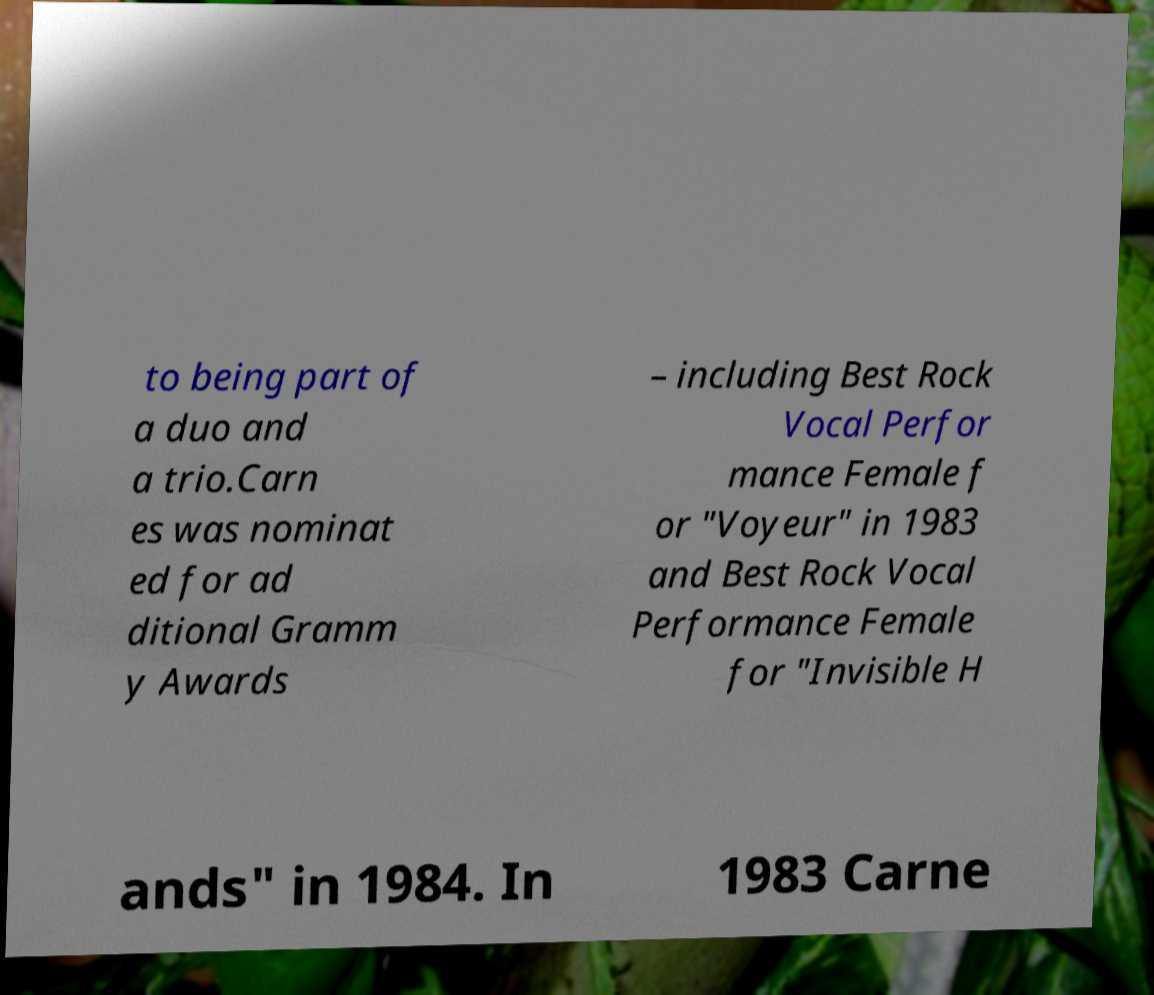Please read and relay the text visible in this image. What does it say? to being part of a duo and a trio.Carn es was nominat ed for ad ditional Gramm y Awards – including Best Rock Vocal Perfor mance Female f or "Voyeur" in 1983 and Best Rock Vocal Performance Female for "Invisible H ands" in 1984. In 1983 Carne 